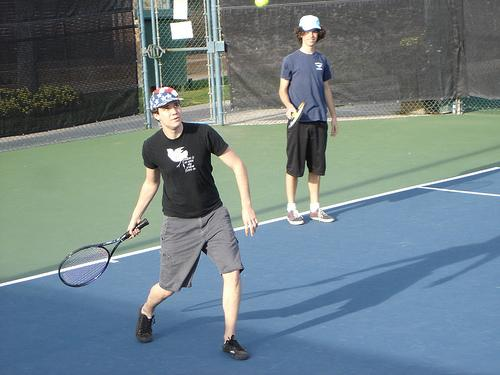In a poetic manner, describe the footwear choice of one of the boys in the image. Upon the lad's nimble feet, one spies a realm of darkness, a black shoe poised to fleet, a sneaker in resplendent blackness. How many hands of the man are visible and mentioned in the input data? Two hands of the man are visible and mentioned. Enumerate the types of hats observed on the boys in the image using the style of Victorian literature. Upon close observation, one shall discern a cap adorned in the colors of the American flag, and a white baseball hat gracing the heads of the youthful gentlemen. What is a noticeable element on the front boy's head in the image? An American flag hat. What type of fence is surrounding the tennis court and what is attached to it? A chain-link fence surrounds the court, with paper and a black cover attached to it. What is the current state of the tennis ball according to the input data? The tennis ball is in the air (floating or flying) and yellow in color. Identify and describe the primary activity in this image using modern slang language. Yo, these two dudes be playin' tennis, showing off their mad skills. Deduce an emotion or sentiment that could be felt by observing the image, based on the text. The sentiment felt may be excitement or enthusiasm as the boys are engaged in a competitive tennis match. In the image, which type of game is being played by two boys? Tennis What is the color of the tennis ball in the air? Yellow What is the color of the print on the black shirt? White Where is the white baseball cap in the image? On a man in the back What kind of accessory is the boy at X:135 Y:88 wearing on his head? American flag hat Explain how the boy holding the black tennis racket is preparing. He is preparing to hit the ball during the tennis match. What object can be found at position X:134 Y:307? A black shoe of a man What is the color of the shorts worn by the boy at X:153 Y:209? Grey Is the soccer goal net visible in the image? If it is not, please add it. No, it's not mentioned in the image. What kind of shoes is the boy wearing without socks? Answer:  What is unique about the boy's hair around X:292 Y:5? He has lots of curly hair Is there a girl with a pink dress in the background? Make her dress more prominent. The image focuses on two boys playing tennis, and there is no mention of a girl or a pink dress in the described objects. This instruction is misleading as it introduces a new character that is not present in the image. Which text can be found in the image? Signs posted on the court gate What do the two boys playing tennis and the white hat on the boy have in common? They are present in the same image. What is the shadow on the tennis courts? A shadow of a boy What is the white print on the chest area of the blue shirt at X:311 Y:58? Unknown, the image does not provide enough detail to determine the print. Identify the type of racket held by the boy at X:53 Y:219. A black tennis racket Describe the role of the man at X:277 Y:11. He is observing his teammate during the tennis match Can you point out where the crowd of people watching the game is located? Focus more on the cheering audience. There is no mention of a crowd or people watching the game in the described objects. This instruction is misleading as it implies there should be an audience present in the image, which is not the case. Describe the style of the hat worn by the boy at X:149 Y:86. Red, white, and blue cap with an American flag theme 